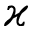<formula> <loc_0><loc_0><loc_500><loc_500>\varkappa</formula> 